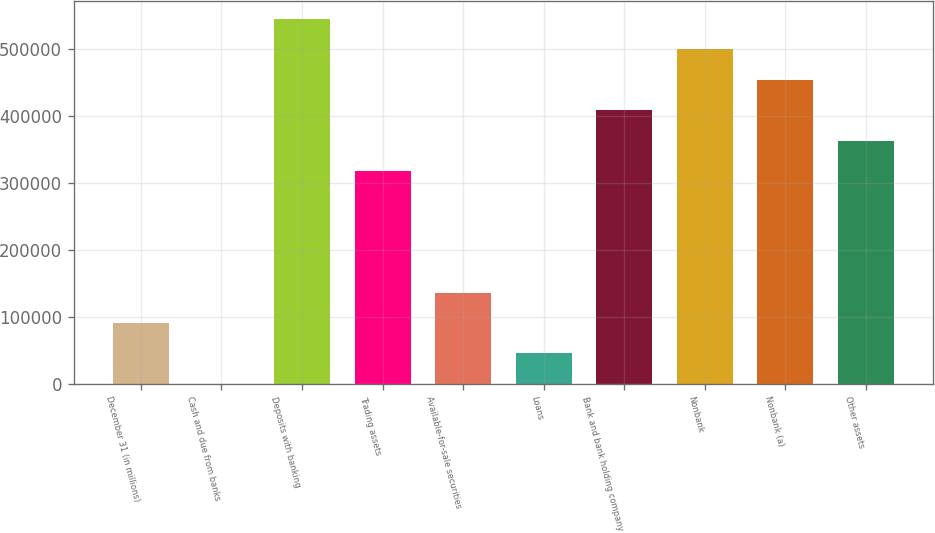Convert chart to OTSL. <chart><loc_0><loc_0><loc_500><loc_500><bar_chart><fcel>December 31 (in millions)<fcel>Cash and due from banks<fcel>Deposits with banking<fcel>Trading assets<fcel>Available-for-sale securities<fcel>Loans<fcel>Bank and bank holding company<fcel>Nonbank<fcel>Nonbank (a)<fcel>Other assets<nl><fcel>90814.8<fcel>74<fcel>544519<fcel>317667<fcel>136185<fcel>45444.4<fcel>408408<fcel>499148<fcel>453778<fcel>363037<nl></chart> 